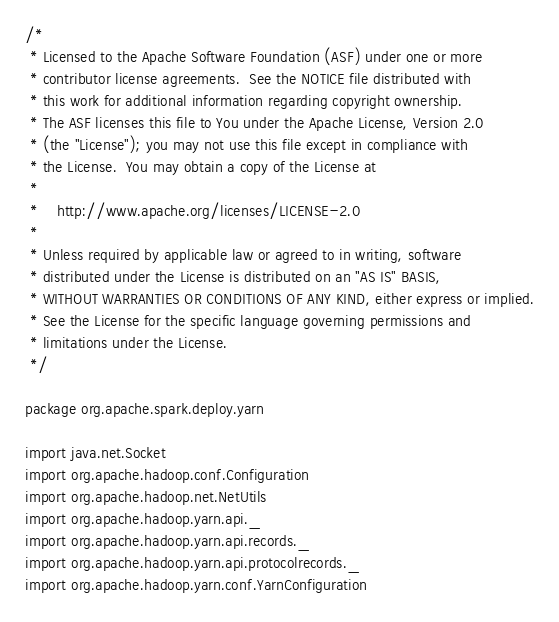<code> <loc_0><loc_0><loc_500><loc_500><_Scala_>/*
 * Licensed to the Apache Software Foundation (ASF) under one or more
 * contributor license agreements.  See the NOTICE file distributed with
 * this work for additional information regarding copyright ownership.
 * The ASF licenses this file to You under the Apache License, Version 2.0
 * (the "License"); you may not use this file except in compliance with
 * the License.  You may obtain a copy of the License at
 *
 *    http://www.apache.org/licenses/LICENSE-2.0
 *
 * Unless required by applicable law or agreed to in writing, software
 * distributed under the License is distributed on an "AS IS" BASIS,
 * WITHOUT WARRANTIES OR CONDITIONS OF ANY KIND, either express or implied.
 * See the License for the specific language governing permissions and
 * limitations under the License.
 */

package org.apache.spark.deploy.yarn

import java.net.Socket
import org.apache.hadoop.conf.Configuration
import org.apache.hadoop.net.NetUtils
import org.apache.hadoop.yarn.api._
import org.apache.hadoop.yarn.api.records._
import org.apache.hadoop.yarn.api.protocolrecords._
import org.apache.hadoop.yarn.conf.YarnConfiguration</code> 